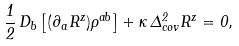<formula> <loc_0><loc_0><loc_500><loc_500>\frac { 1 } { 2 } \, D _ { b } \left [ ( \partial _ { a } R ^ { z } ) \rho ^ { a b } \right ] + \kappa \, \Delta ^ { 2 } _ { c o v } R ^ { z } = 0 ,</formula> 